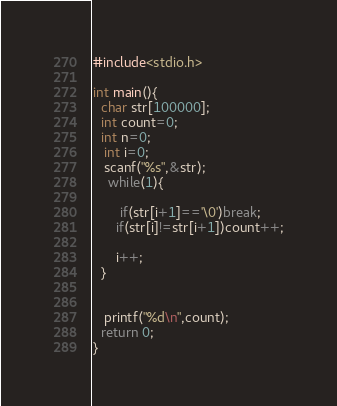Convert code to text. <code><loc_0><loc_0><loc_500><loc_500><_C_>#include<stdio.h>

int main(){
  char str[100000];
  int count=0;
  int n=0;
   int i=0;
   scanf("%s",&str);
    while(1){

       if(str[i+1]=='\0')break;
      if(str[i]!=str[i+1])count++;
   
      i++;
  }
    
   
   printf("%d\n",count);
  return 0;
}
</code> 